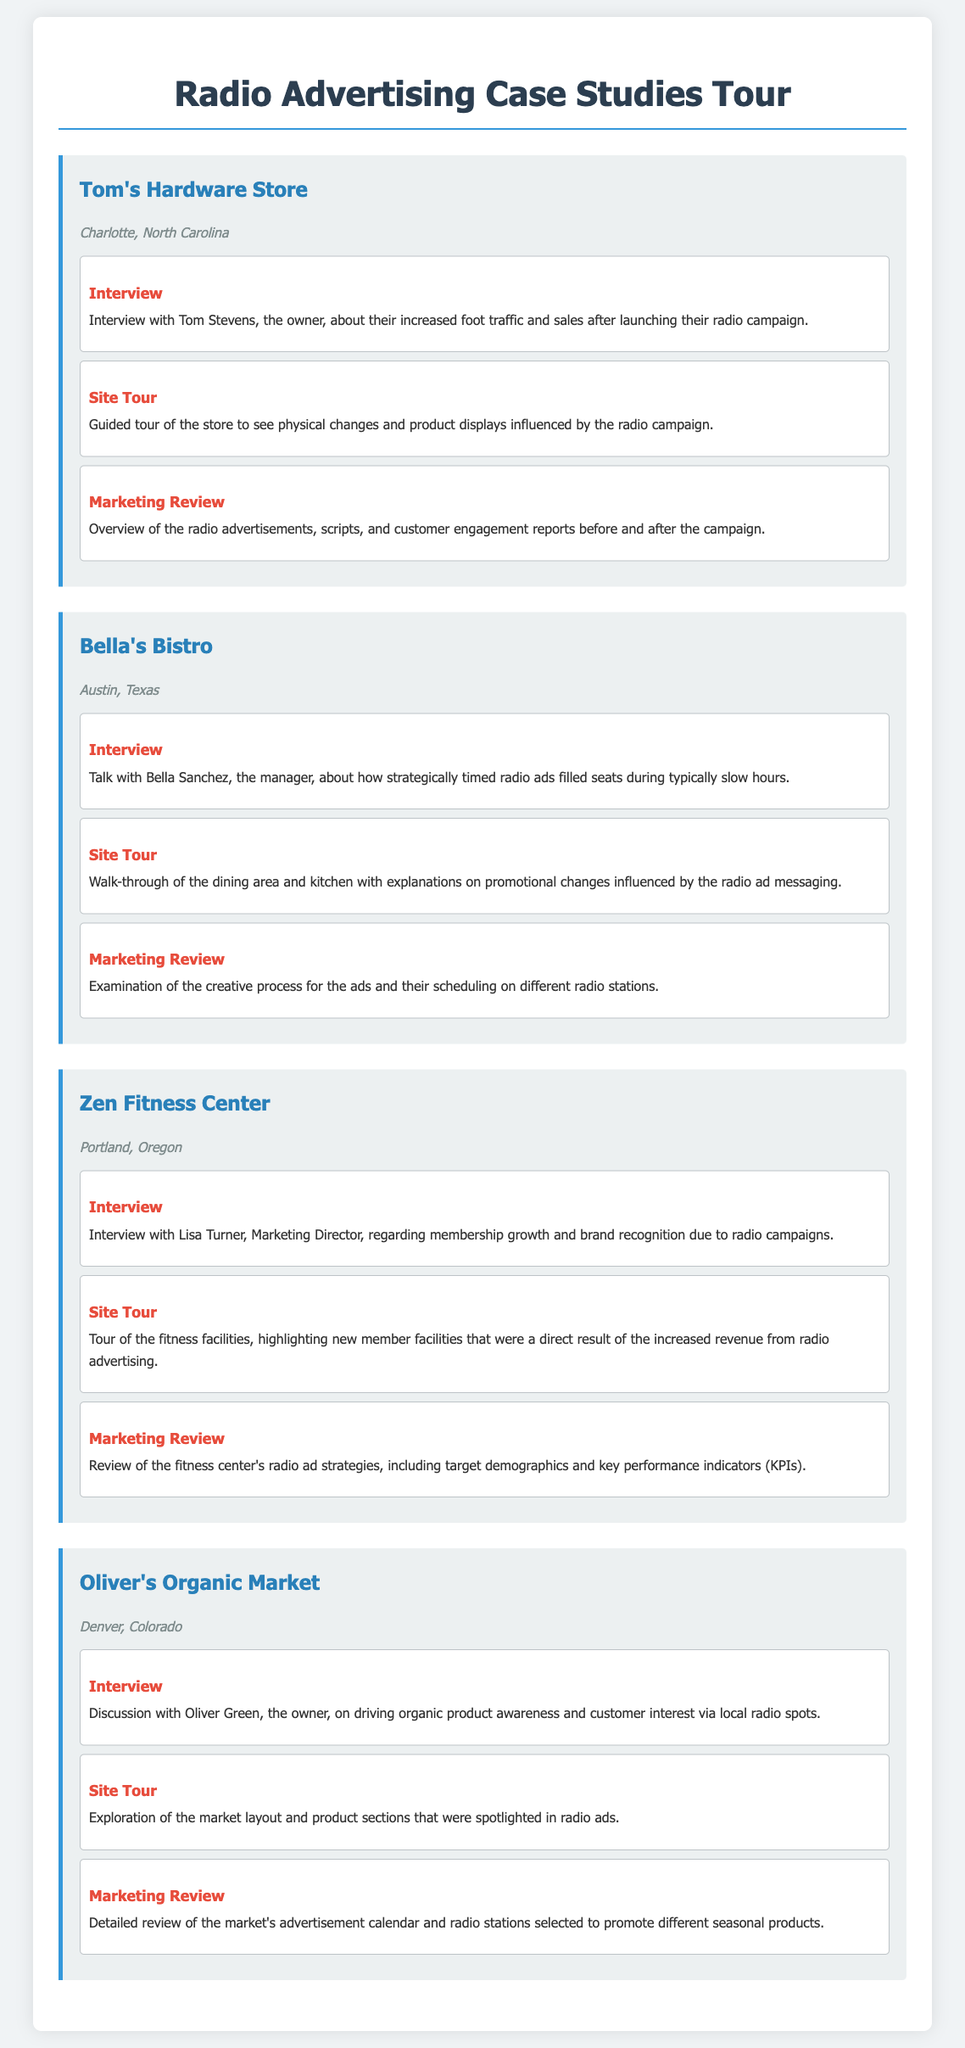What is the name of the hardware store featured in the tour? The name of the hardware store is Tom's Hardware Store.
Answer: Tom's Hardware Store In which city is Bella's Bistro located? Bella's Bistro is located in Austin, Texas.
Answer: Austin, Texas Who is the owner of Oliver's Organic Market? The owner of Oliver's Organic Market is Oliver Green.
Answer: Oliver Green What type of business is Zen Fitness Center? Zen Fitness Center is a fitness facility.
Answer: Fitness Center What was the focus of Tom Stevens' interview? The interview focused on increased foot traffic and sales after launching their radio campaign.
Answer: Increased foot traffic and sales Which business used strategically timed radio ads? Bella's Bistro used strategically timed radio ads to fill seats.
Answer: Bella's Bistro How did Oliver's Organic Market promote its products? Oliver's Organic Market promoted its products through local radio spots.
Answer: Local radio spots What was a result of the revenue from radio advertising for Zen Fitness Center? The revenue from radio advertising led to new member facilities being developed.
Answer: New member facilities What did the marketing review for Tom's Hardware Store include? The marketing review included an overview of radio advertisements, scripts, and customer engagement reports.
Answer: Overview of radio advertisements, scripts, and customer engagement reports 